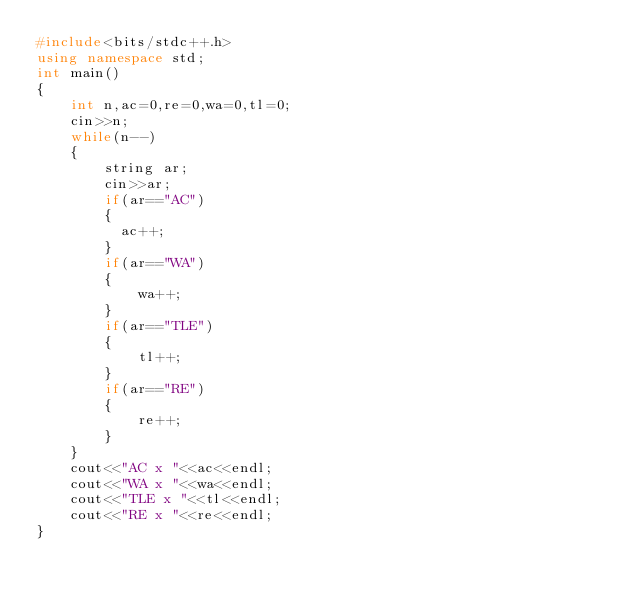Convert code to text. <code><loc_0><loc_0><loc_500><loc_500><_C++_>#include<bits/stdc++.h>
using namespace std;
int main()
{
    int n,ac=0,re=0,wa=0,tl=0;
    cin>>n;
    while(n--)
    {
        string ar;
        cin>>ar;
        if(ar=="AC")
        {
          ac++;
        }
        if(ar=="WA")
        {
            wa++;
        }
        if(ar=="TLE")
        {
            tl++;
        }
        if(ar=="RE")
        {
            re++;
        }
    }
    cout<<"AC x "<<ac<<endl;
    cout<<"WA x "<<wa<<endl;
    cout<<"TLE x "<<tl<<endl;
    cout<<"RE x "<<re<<endl;
}
</code> 